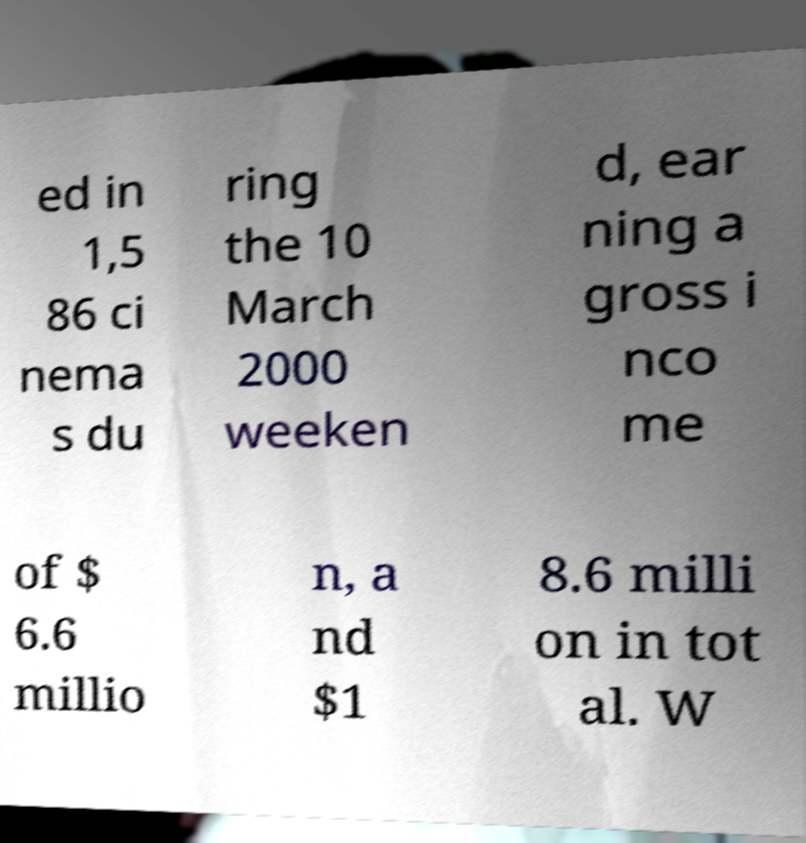Please identify and transcribe the text found in this image. ed in 1,5 86 ci nema s du ring the 10 March 2000 weeken d, ear ning a gross i nco me of $ 6.6 millio n, a nd $1 8.6 milli on in tot al. W 